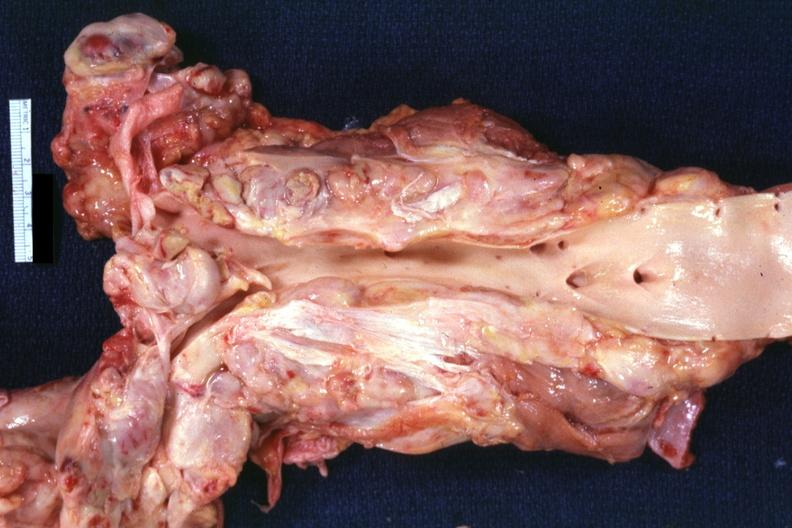s hodgkins disease present?
Answer the question using a single word or phrase. Yes 